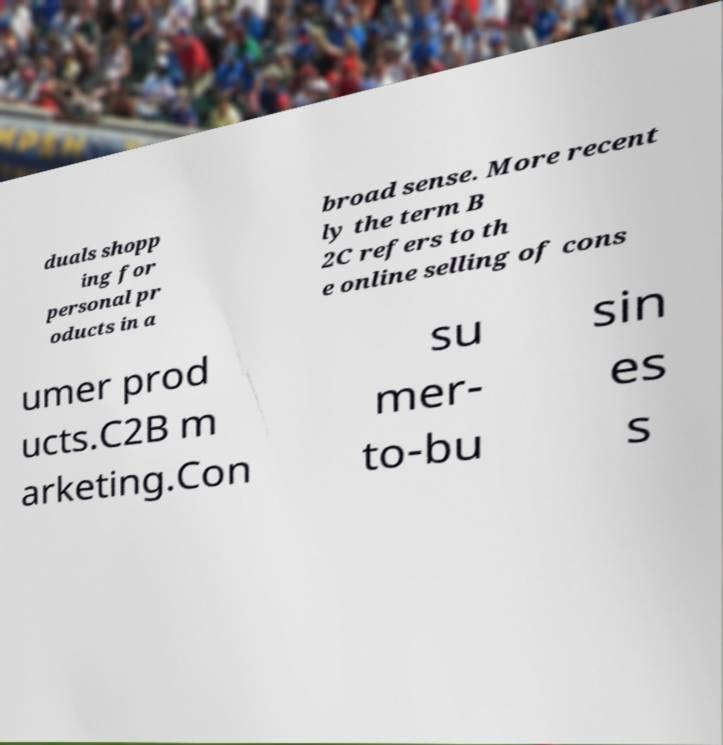Could you extract and type out the text from this image? duals shopp ing for personal pr oducts in a broad sense. More recent ly the term B 2C refers to th e online selling of cons umer prod ucts.C2B m arketing.Con su mer- to-bu sin es s 